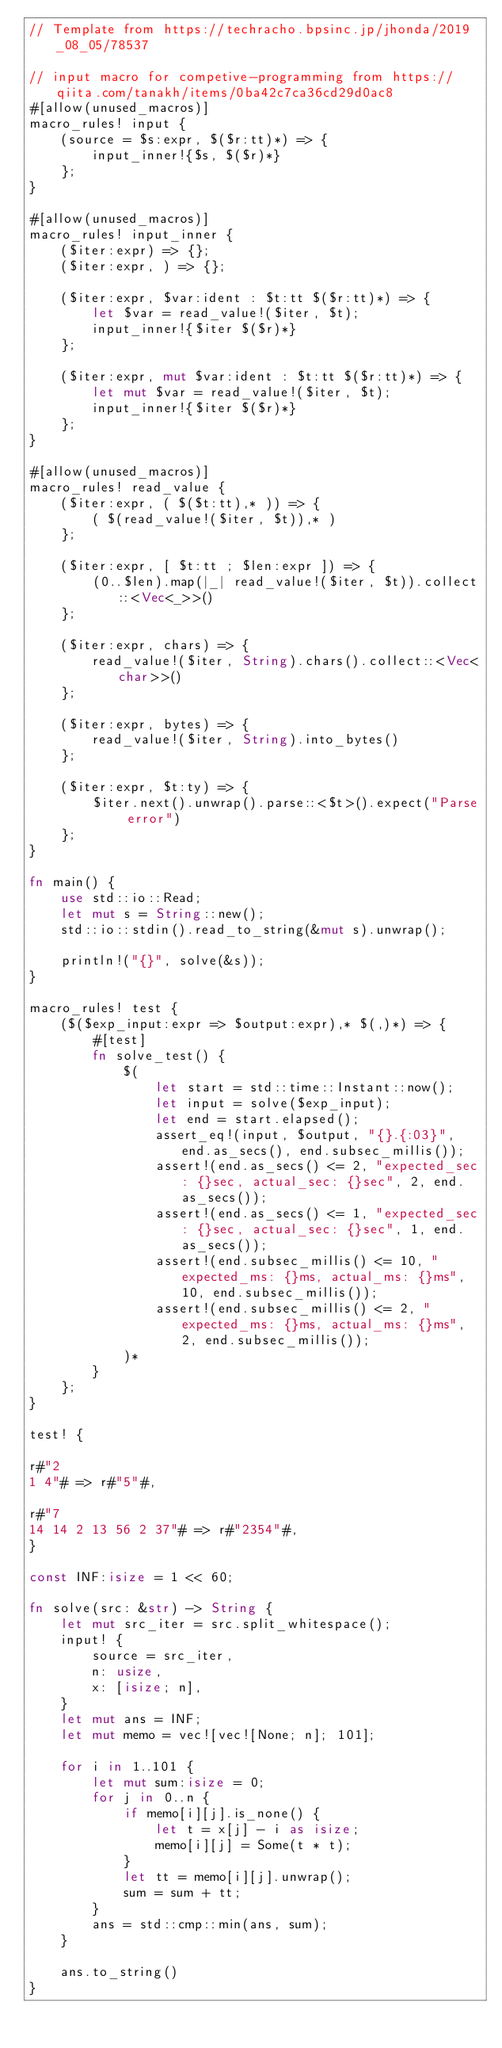<code> <loc_0><loc_0><loc_500><loc_500><_Rust_>// Template from https://techracho.bpsinc.jp/jhonda/2019_08_05/78537

// input macro for competive-programming from https://qiita.com/tanakh/items/0ba42c7ca36cd29d0ac8
#[allow(unused_macros)]
macro_rules! input {
    (source = $s:expr, $($r:tt)*) => {
        input_inner!{$s, $($r)*}
    };
}

#[allow(unused_macros)]
macro_rules! input_inner {
    ($iter:expr) => {};
    ($iter:expr, ) => {};

    ($iter:expr, $var:ident : $t:tt $($r:tt)*) => {
        let $var = read_value!($iter, $t);
        input_inner!{$iter $($r)*}
    };

    ($iter:expr, mut $var:ident : $t:tt $($r:tt)*) => {
        let mut $var = read_value!($iter, $t);
        input_inner!{$iter $($r)*}
    };
}

#[allow(unused_macros)]
macro_rules! read_value {
    ($iter:expr, ( $($t:tt),* )) => {
        ( $(read_value!($iter, $t)),* )
    };

    ($iter:expr, [ $t:tt ; $len:expr ]) => {
        (0..$len).map(|_| read_value!($iter, $t)).collect::<Vec<_>>()
    };

    ($iter:expr, chars) => {
        read_value!($iter, String).chars().collect::<Vec<char>>()
    };

    ($iter:expr, bytes) => {
        read_value!($iter, String).into_bytes()
    };

    ($iter:expr, $t:ty) => {
        $iter.next().unwrap().parse::<$t>().expect("Parse error")
    };
}

fn main() {
    use std::io::Read;
    let mut s = String::new();
    std::io::stdin().read_to_string(&mut s).unwrap();

    println!("{}", solve(&s));
}

macro_rules! test {
    ($($exp_input:expr => $output:expr),* $(,)*) => {
        #[test]
        fn solve_test() {
            $(
                let start = std::time::Instant::now();
                let input = solve($exp_input);
                let end = start.elapsed();
                assert_eq!(input, $output, "{}.{:03}", end.as_secs(), end.subsec_millis());
                assert!(end.as_secs() <= 2, "expected_sec: {}sec, actual_sec: {}sec", 2, end.as_secs());
                assert!(end.as_secs() <= 1, "expected_sec: {}sec, actual_sec: {}sec", 1, end.as_secs());
                assert!(end.subsec_millis() <= 10, "expected_ms: {}ms, actual_ms: {}ms", 10, end.subsec_millis());
                assert!(end.subsec_millis() <= 2, "expected_ms: {}ms, actual_ms: {}ms", 2, end.subsec_millis());
            )*
        }
    };
}

test! {

r#"2
1 4"# => r#"5"#,

r#"7
14 14 2 13 56 2 37"# => r#"2354"#,
}

const INF:isize = 1 << 60;

fn solve(src: &str) -> String {
    let mut src_iter = src.split_whitespace();
    input! {
        source = src_iter,
        n: usize,
        x: [isize; n],
    }
    let mut ans = INF;
    let mut memo = vec![vec![None; n]; 101];

    for i in 1..101 {
        let mut sum:isize = 0;
        for j in 0..n {
            if memo[i][j].is_none() {
                let t = x[j] - i as isize;
                memo[i][j] = Some(t * t);
            }
            let tt = memo[i][j].unwrap();
            sum = sum + tt;
        }
        ans = std::cmp::min(ans, sum);
    }

    ans.to_string()
}</code> 